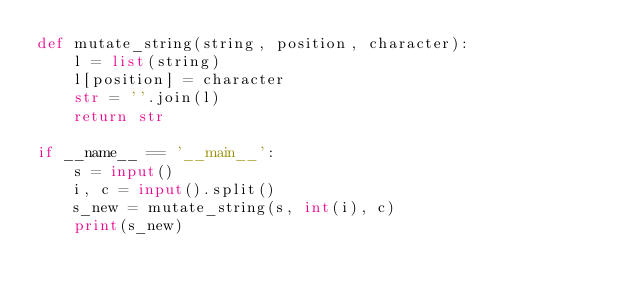<code> <loc_0><loc_0><loc_500><loc_500><_Python_>def mutate_string(string, position, character):
    l = list(string)
    l[position] = character
    str = ''.join(l)
    return str

if __name__ == '__main__':
    s = input()
    i, c = input().split()
    s_new = mutate_string(s, int(i), c)
    print(s_new)</code> 